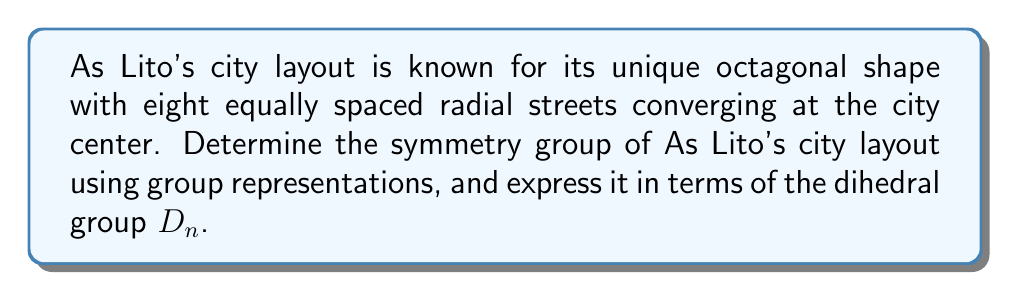Help me with this question. To determine the symmetry group of As Lito's octagonal city layout, we'll follow these steps:

1. Identify the symmetries:
   - Rotational symmetries: The layout has 8-fold rotational symmetry.
   - Reflection symmetries: There are 8 lines of reflection (4 through opposite corners and 4 through the midpoints of opposite sides).

2. Recognize the group structure:
   The symmetry group of a regular octagon is isomorphic to the dihedral group $D_8$.

3. Express the group using representations:
   The dihedral group $D_8$ has two standard representations:
   a) Rotations: $r_k = e^{2\pi i k / 8}$ for $k = 0, 1, ..., 7$
   b) Reflections: $s_k = r_k \cdot s_0$, where $s_0$ is the reflection across the x-axis

4. Group structure:
   $$D_8 = \langle r, s | r^8 = s^2 = 1, srs = r^{-1} \rangle$$

5. Character table for $D_8$:
   $$\begin{array}{c|ccccc}
   D_8 & E & 2C_8 & 2C_4 & 2C_8^3 & C_2 & 4\sigma_v & 4\sigma_d \\
   \hline
   A_1 & 1 & 1 & 1 & 1 & 1 & 1 & 1 \\
   A_2 & 1 & 1 & 1 & 1 & 1 & -1 & -1 \\
   B_1 & 1 & -1 & 1 & -1 & 1 & 1 & -1 \\
   B_2 & 1 & -1 & 1 & -1 & 1 & -1 & 1 \\
   E_1 & 2 & \sqrt{2} & 0 & -\sqrt{2} & -2 & 0 & 0 \\
   E_2 & 2 & -\sqrt{2} & 0 & \sqrt{2} & -2 & 0 & 0 \\
   E_3 & 2 & 0 & -2 & 0 & 2 & 0 & 0
   \end{array}$$

The symmetry group of As Lito's city layout is thus represented by the dihedral group $D_8$, which captures all the rotational and reflectional symmetries of the octagonal layout.
Answer: $D_8$ 